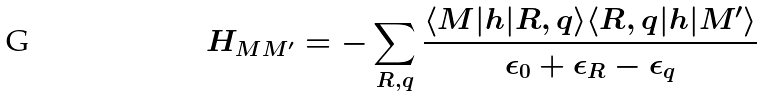Convert formula to latex. <formula><loc_0><loc_0><loc_500><loc_500>H _ { M M ^ { \prime } } = - \sum _ { R , q } \frac { \langle M | h | R , q \rangle \langle R , q | h | M ^ { \prime } \rangle } { \epsilon _ { 0 } + \epsilon _ { R } - \epsilon _ { q } }</formula> 